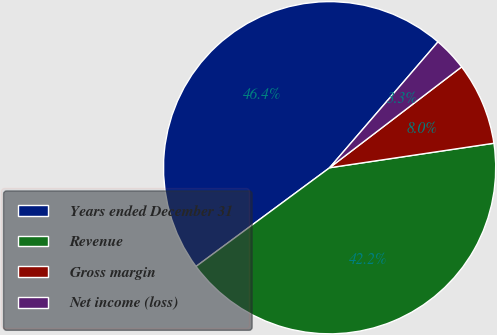<chart> <loc_0><loc_0><loc_500><loc_500><pie_chart><fcel>Years ended December 31<fcel>Revenue<fcel>Gross margin<fcel>Net income (loss)<nl><fcel>46.45%<fcel>42.23%<fcel>8.03%<fcel>3.3%<nl></chart> 